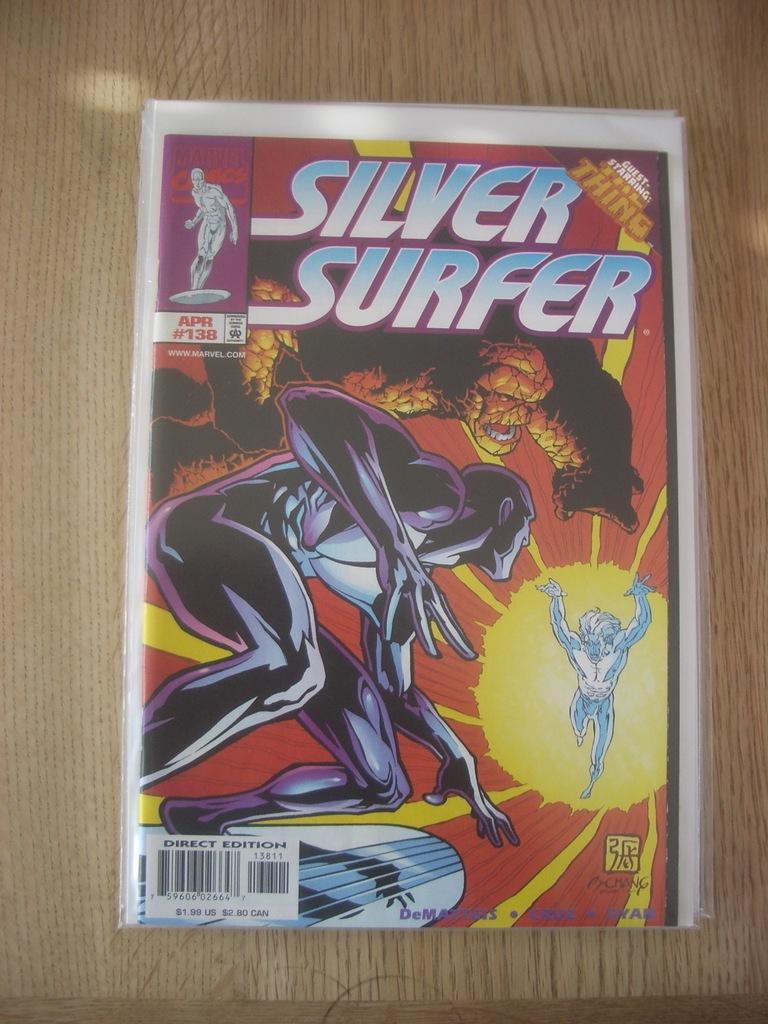What is the title of the comic?
Give a very brief answer. Silver surfer. 